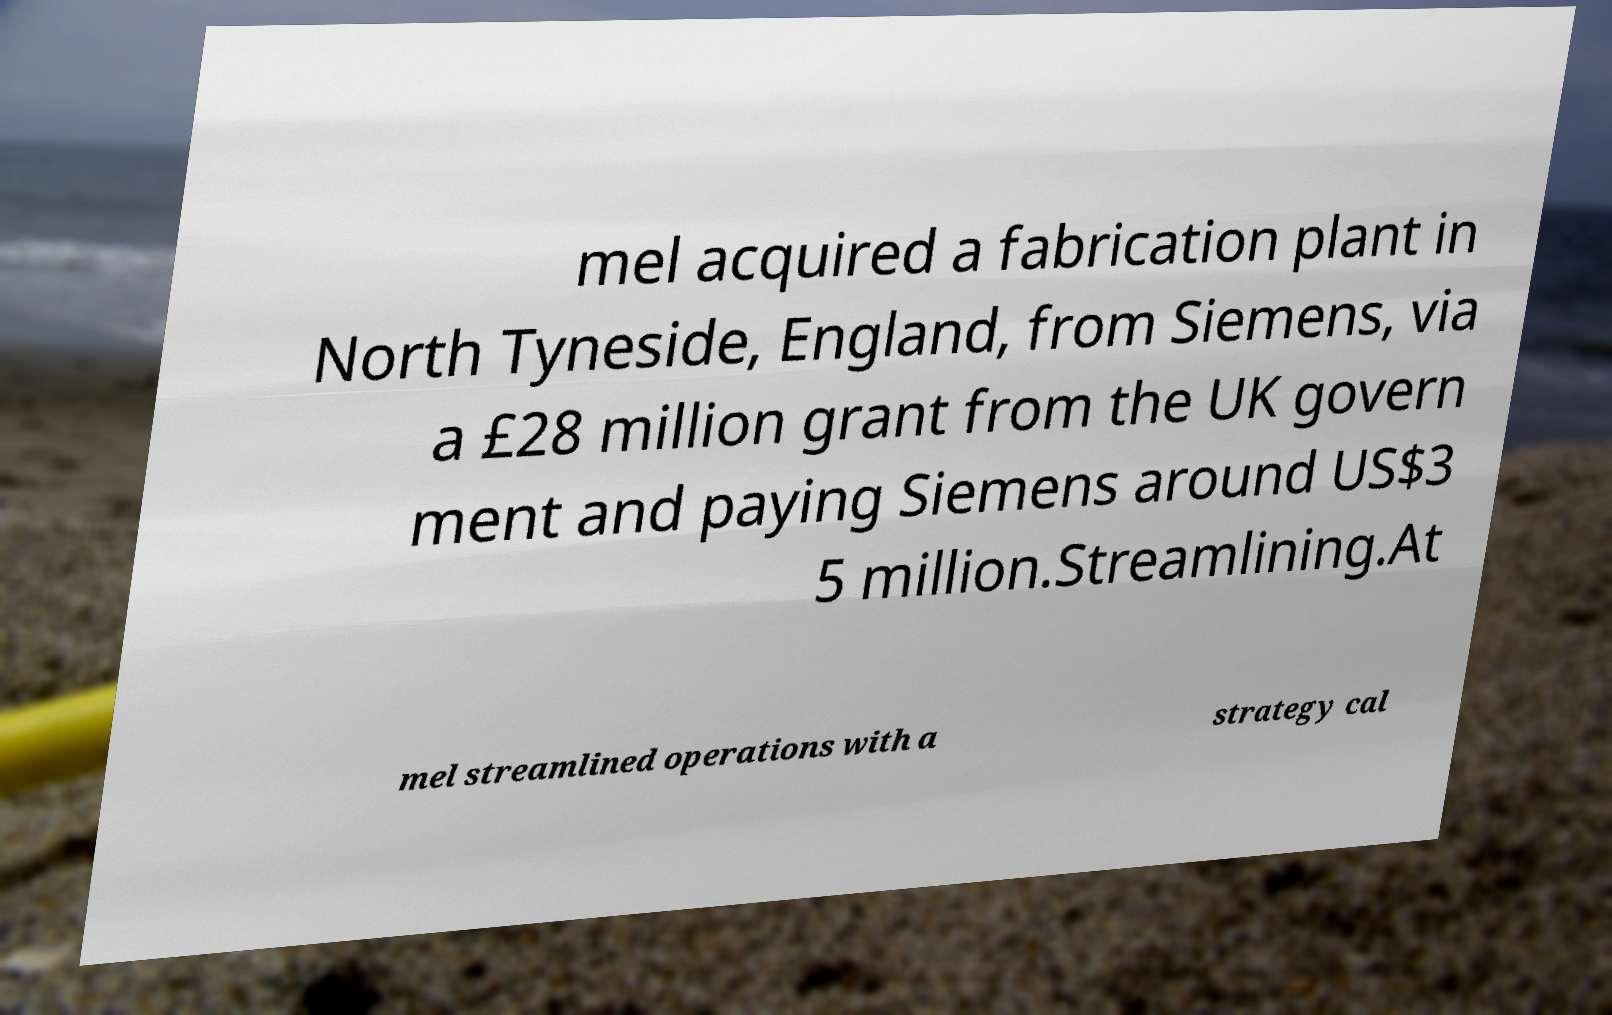Please read and relay the text visible in this image. What does it say? mel acquired a fabrication plant in North Tyneside, England, from Siemens, via a £28 million grant from the UK govern ment and paying Siemens around US$3 5 million.Streamlining.At mel streamlined operations with a strategy cal 